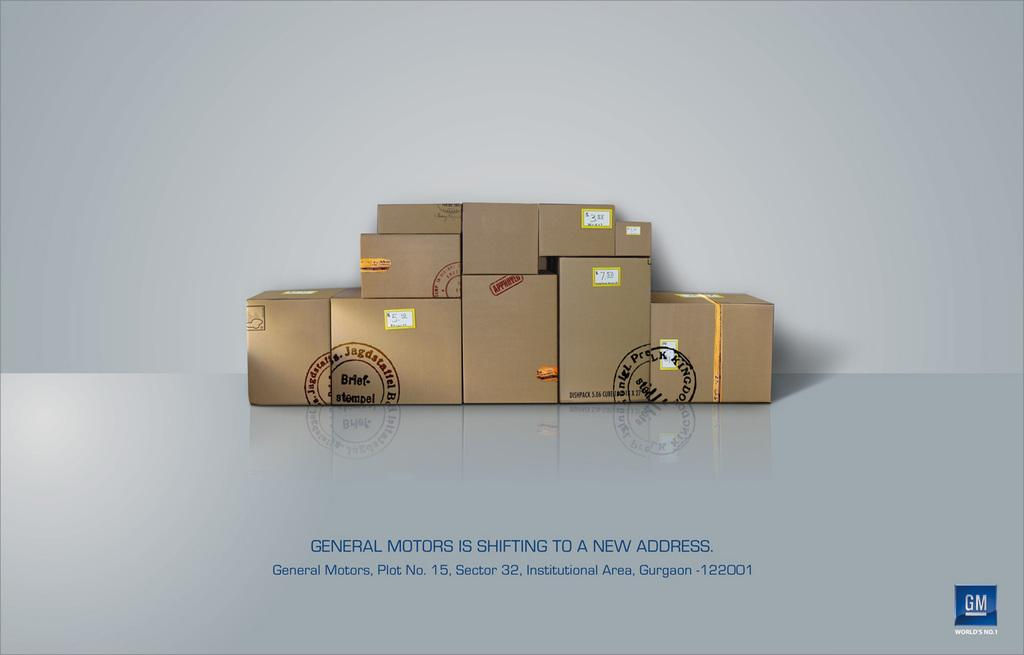<image>
Create a compact narrative representing the image presented. Several cardboard boxes full of General Motors parts. 